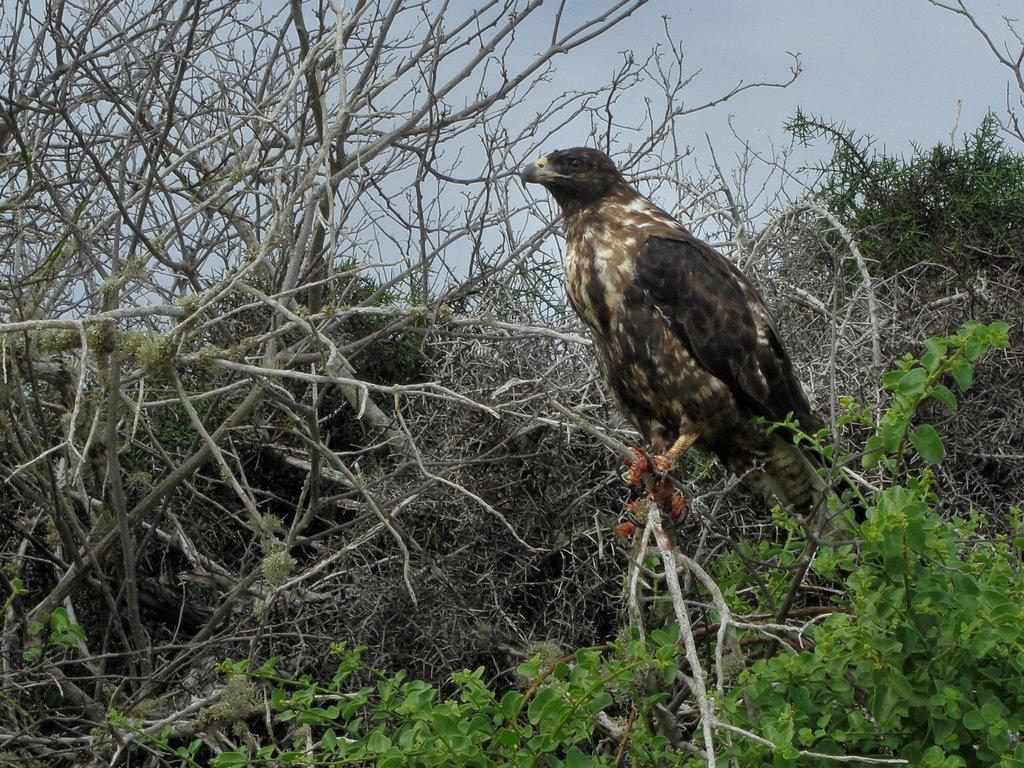Could you give a brief overview of what you see in this image? In this picture we can see a bird and in the background we can see trees, sky. 